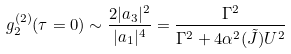Convert formula to latex. <formula><loc_0><loc_0><loc_500><loc_500>g ^ { ( 2 ) } _ { 2 } ( \tau = 0 ) \sim \frac { 2 | a _ { 3 } | ^ { 2 } } { | a _ { 1 } | ^ { 4 } } = \frac { \Gamma ^ { 2 } } { \Gamma ^ { 2 } + 4 \alpha ^ { 2 } ( \tilde { J } ) U ^ { 2 } }</formula> 